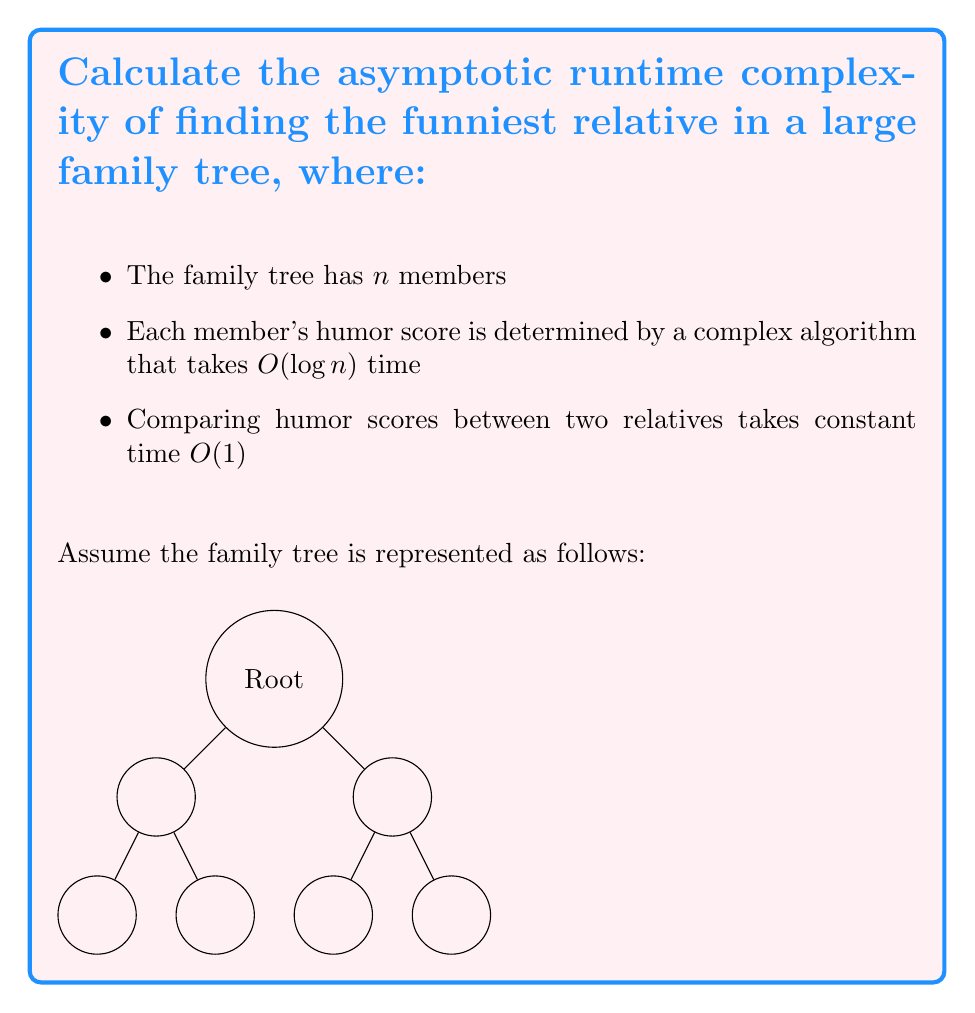Provide a solution to this math problem. Let's break this down step-by-step:

1) First, we need to calculate the humor score for each family member. This takes $O(\log n)$ time per member, and we have $n$ members. So, the total time for this step is:

   $O(n \log n)$

2) After calculating all humor scores, we need to find the maximum among them. This is equivalent to finding the maximum element in an array of $n$ elements.

3) The most straightforward way to find the maximum is to iterate through all elements once, keeping track of the highest score seen so far. This takes linear time:

   $O(n)$

4) Comparing humor scores between two relatives takes constant time $O(1)$, so it doesn't affect our asymptotic analysis.

5) The total runtime is the sum of the time to calculate all scores and the time to find the maximum:

   $O(n \log n) + O(n) = O(n \log n)$

6) In asymptotic analysis, we keep only the dominant term. Since $n \log n$ grows faster than $n$, our final runtime complexity is:

   $O(n \log n)$

This algorithm is more efficient than comparing every pair of relatives, which would take $O(n^2)$ time.
Answer: $O(n \log n)$ 